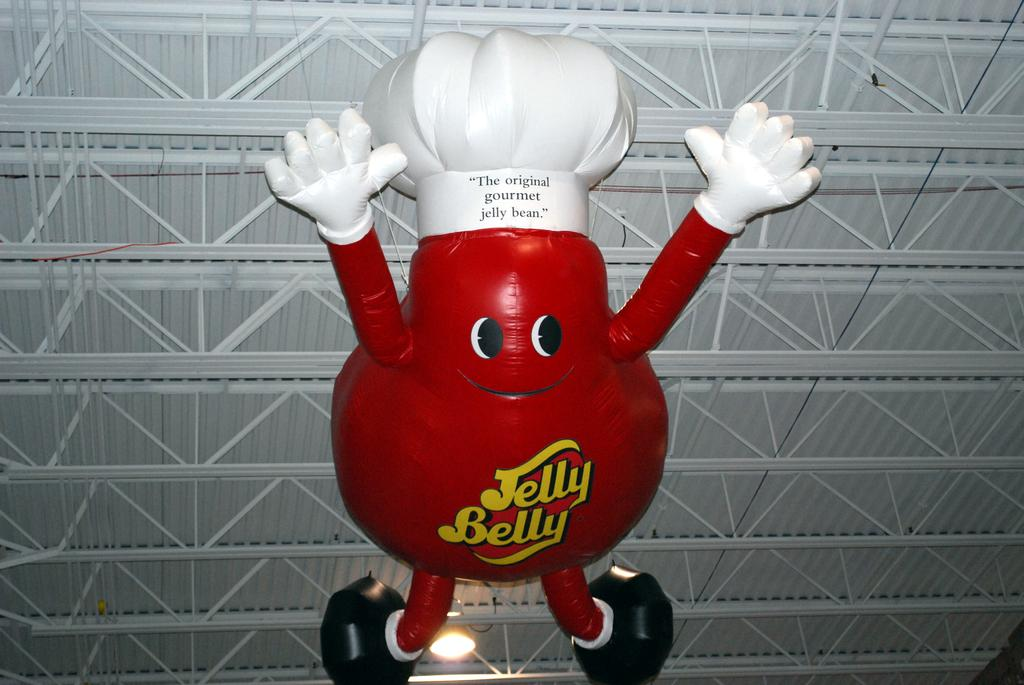What is the prominent color of the cartoon balloon in the image? The cartoon balloon in the image is red. Where is the cartoon balloon located in the image? The cartoon balloon is in the front of the image. What structure can be seen in the image with a metal frame? There is a metal frame with a shed on top in the image. Are there any cacti visible in the image? There is no mention of cacti in the provided facts, so we cannot determine if they are present in the image. 